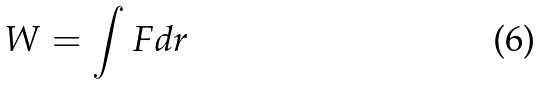<formula> <loc_0><loc_0><loc_500><loc_500>W = \int F d r</formula> 